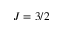<formula> <loc_0><loc_0><loc_500><loc_500>J = 3 / 2</formula> 